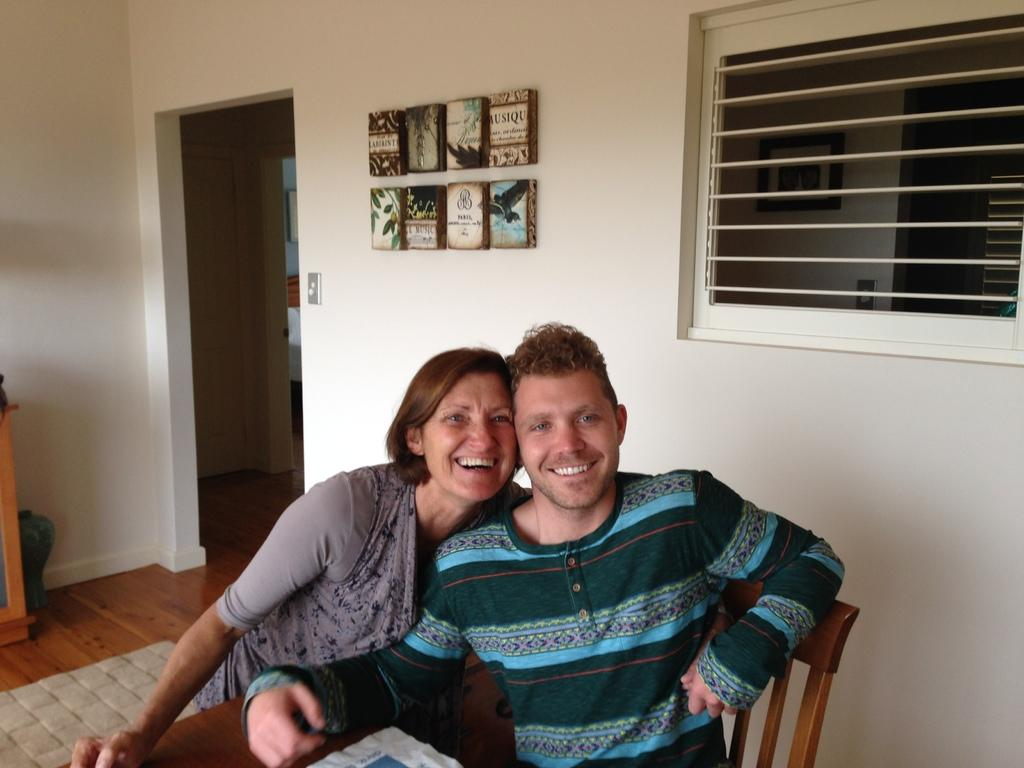Who is present in the image? There is a man and a woman in the image. What are the facial expressions of the people in the image? Both the man and the woman are smiling. What is the man doing in the image? The man is sitting on a chair. What type of hook can be seen hanging from the ceiling in the image? There is no hook visible in the image. What kind of oil is being used by the man in the image? There is no oil or any indication of oil usage in the image. 